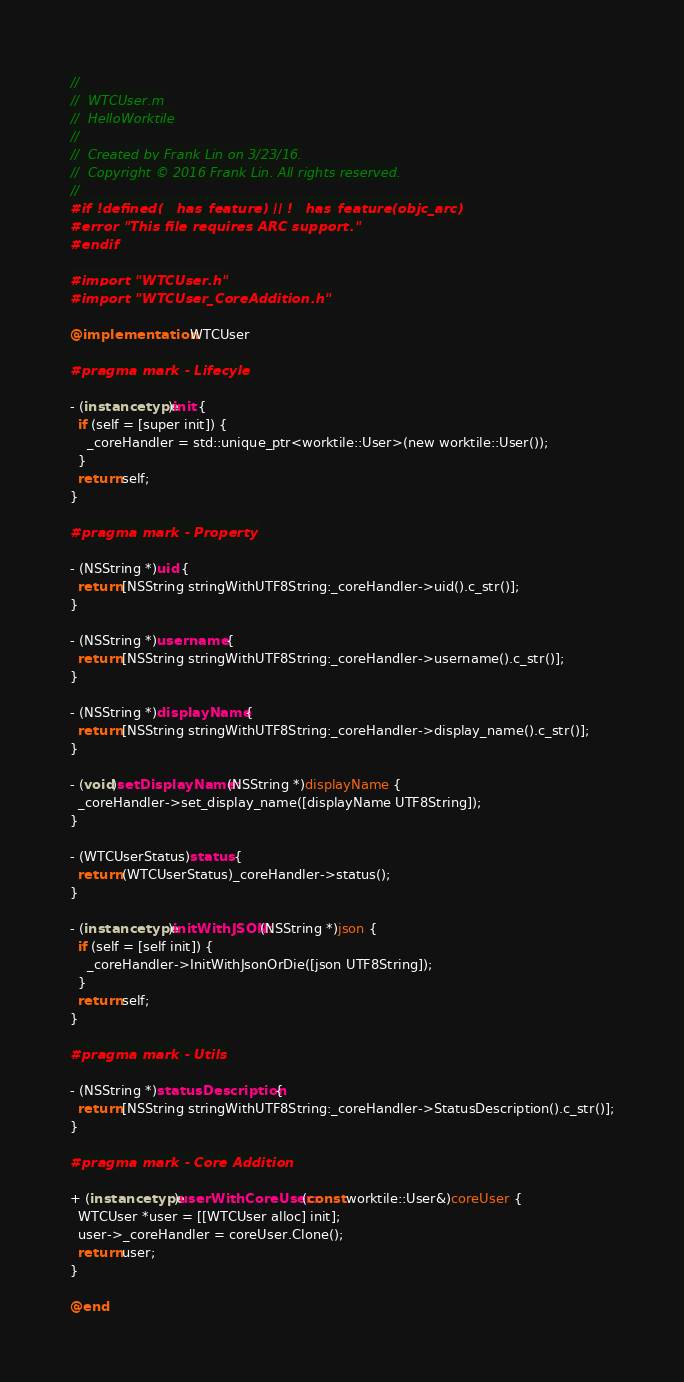<code> <loc_0><loc_0><loc_500><loc_500><_ObjectiveC_>//
//  WTCUser.m
//  HelloWorktile
//
//  Created by Frank Lin on 3/23/16.
//  Copyright © 2016 Frank Lin. All rights reserved.
//
#if !defined(__has_feature) || !__has_feature(objc_arc)
#error "This file requires ARC support."
#endif

#import "WTCUser.h"
#import "WTCUser_CoreAddition.h"

@implementation WTCUser

#pragma mark - Lifecyle

- (instancetype)init {
  if (self = [super init]) {
    _coreHandler = std::unique_ptr<worktile::User>(new worktile::User());
  }
  return self;
}

#pragma mark - Property

- (NSString *)uid {
  return [NSString stringWithUTF8String:_coreHandler->uid().c_str()];
}

- (NSString *)username {
  return [NSString stringWithUTF8String:_coreHandler->username().c_str()];
}

- (NSString *)displayName {
  return [NSString stringWithUTF8String:_coreHandler->display_name().c_str()];
}

- (void)setDisplayName:(NSString *)displayName {
  _coreHandler->set_display_name([displayName UTF8String]);
}

- (WTCUserStatus)status {
  return (WTCUserStatus)_coreHandler->status();
}

- (instancetype)initWithJSON:(NSString *)json {
  if (self = [self init]) {
    _coreHandler->InitWithJsonOrDie([json UTF8String]);
  }
  return self;
}

#pragma mark - Utils

- (NSString *)statusDescription {
  return [NSString stringWithUTF8String:_coreHandler->StatusDescription().c_str()];
}

#pragma mark - Core Addition

+ (instancetype)userWithCoreUser:(const worktile::User&)coreUser {
  WTCUser *user = [[WTCUser alloc] init];
  user->_coreHandler = coreUser.Clone();
  return user;
}

@end
</code> 